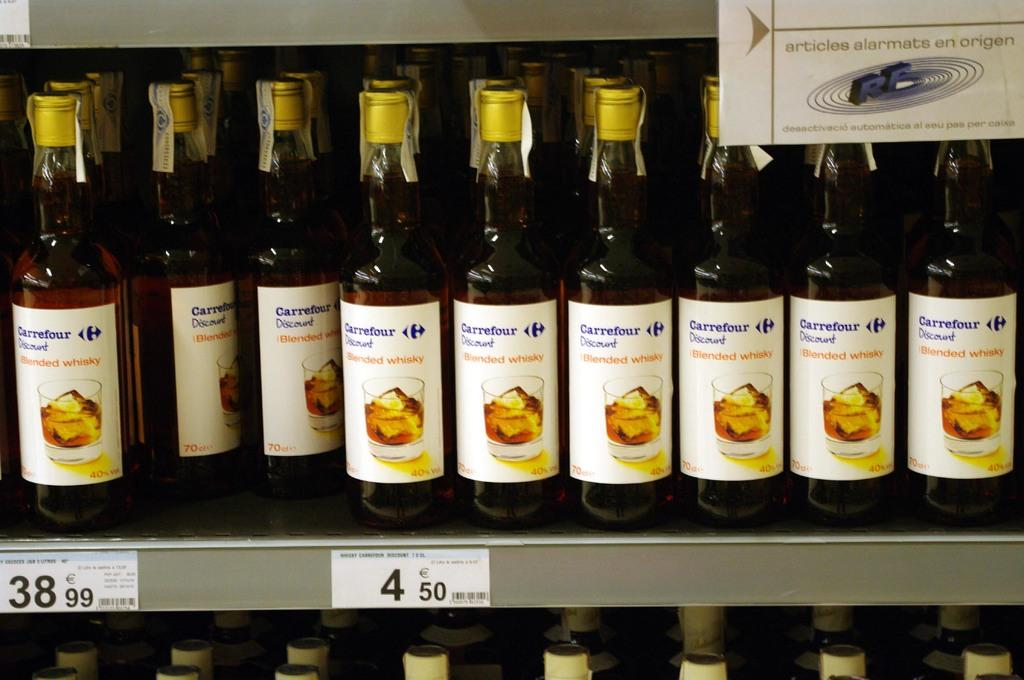<image>
Render a clear and concise summary of the photo. A display of Carrefour Blended Whiskey sits on the shelf 